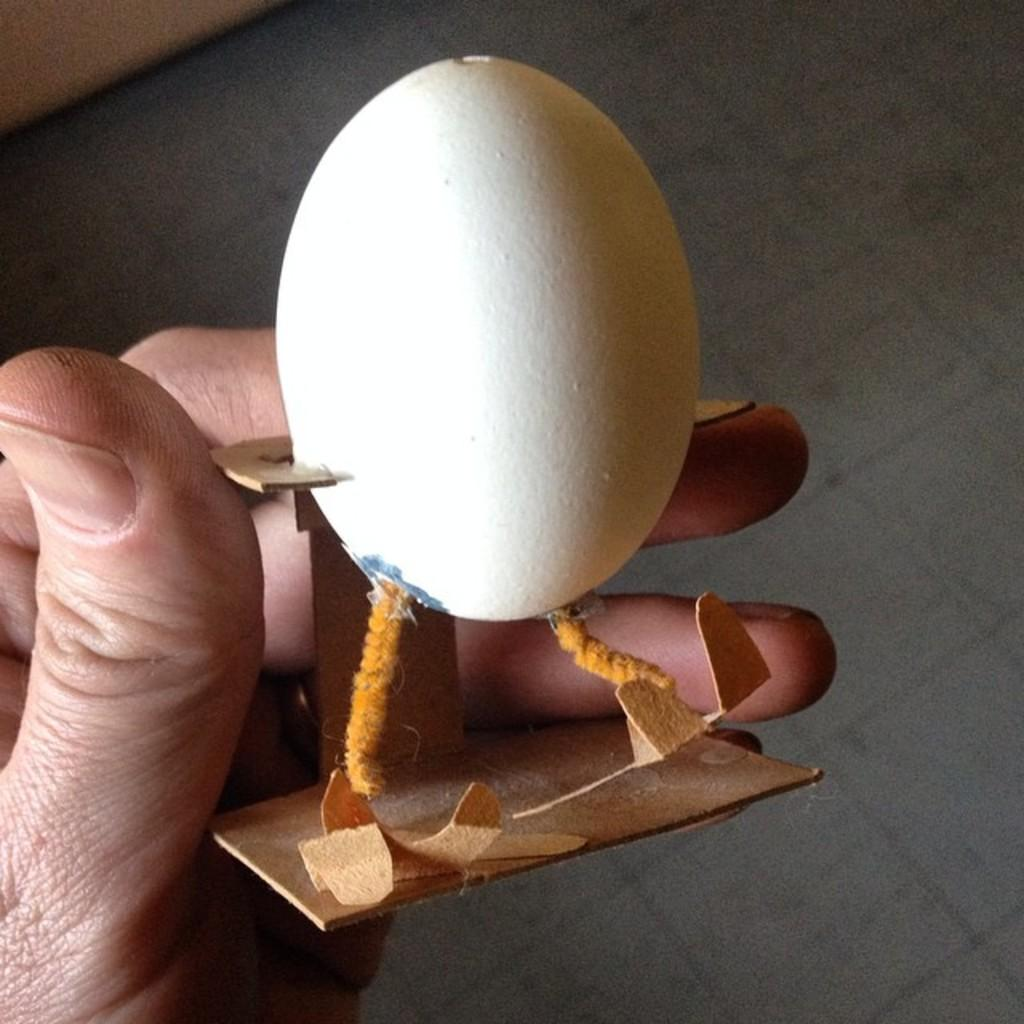What is the person in the image holding? The person is holding an object in the image. What is inside the object being held? There is an egg in the object. What can be seen in the background of the image? The background of the image includes the floor. How many frogs are jumping out of the mitten in the image? There is no mitten or frogs present in the image. 